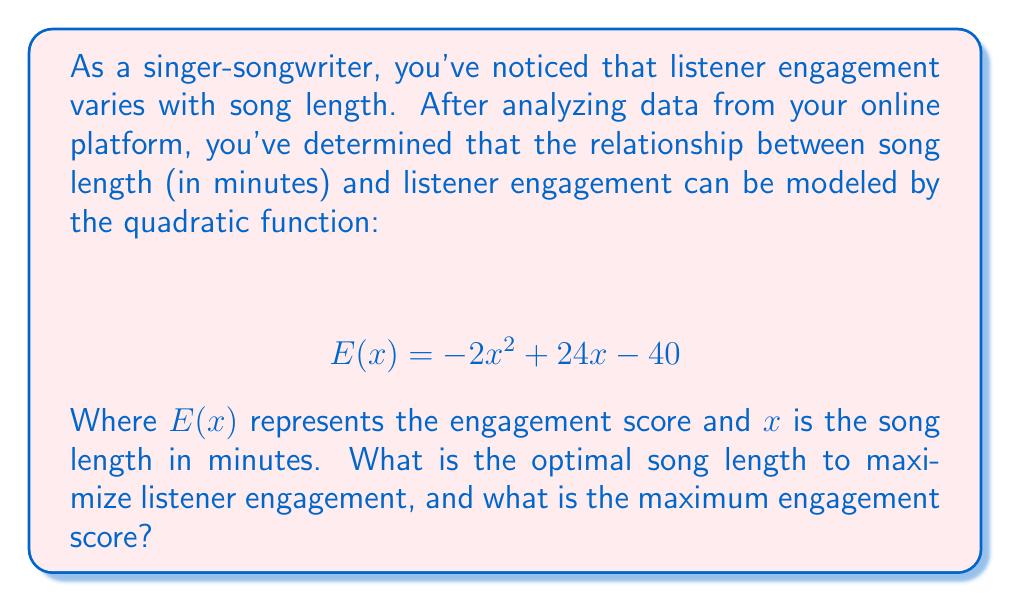Help me with this question. To find the optimal song length and maximum engagement score, we need to follow these steps:

1) The quadratic function is in the form $f(x) = ax^2 + bx + c$, where $a = -2$, $b = 24$, and $c = -40$.

2) For a quadratic function, the x-coordinate of the vertex represents the optimal input value (in this case, the optimal song length). We can find this using the formula:

   $$ x = -\frac{b}{2a} $$

3) Substituting our values:

   $$ x = -\frac{24}{2(-2)} = -\frac{24}{-4} = 6 $$

4) Therefore, the optimal song length is 6 minutes.

5) To find the maximum engagement score, we need to evaluate $E(x)$ at $x = 6$:

   $$ E(6) = -2(6)^2 + 24(6) - 40 $$
   $$ = -2(36) + 144 - 40 $$
   $$ = -72 + 144 - 40 $$
   $$ = 32 $$

Thus, the maximum engagement score is 32.
Answer: Optimal song length: 6 minutes; Maximum engagement score: 32 